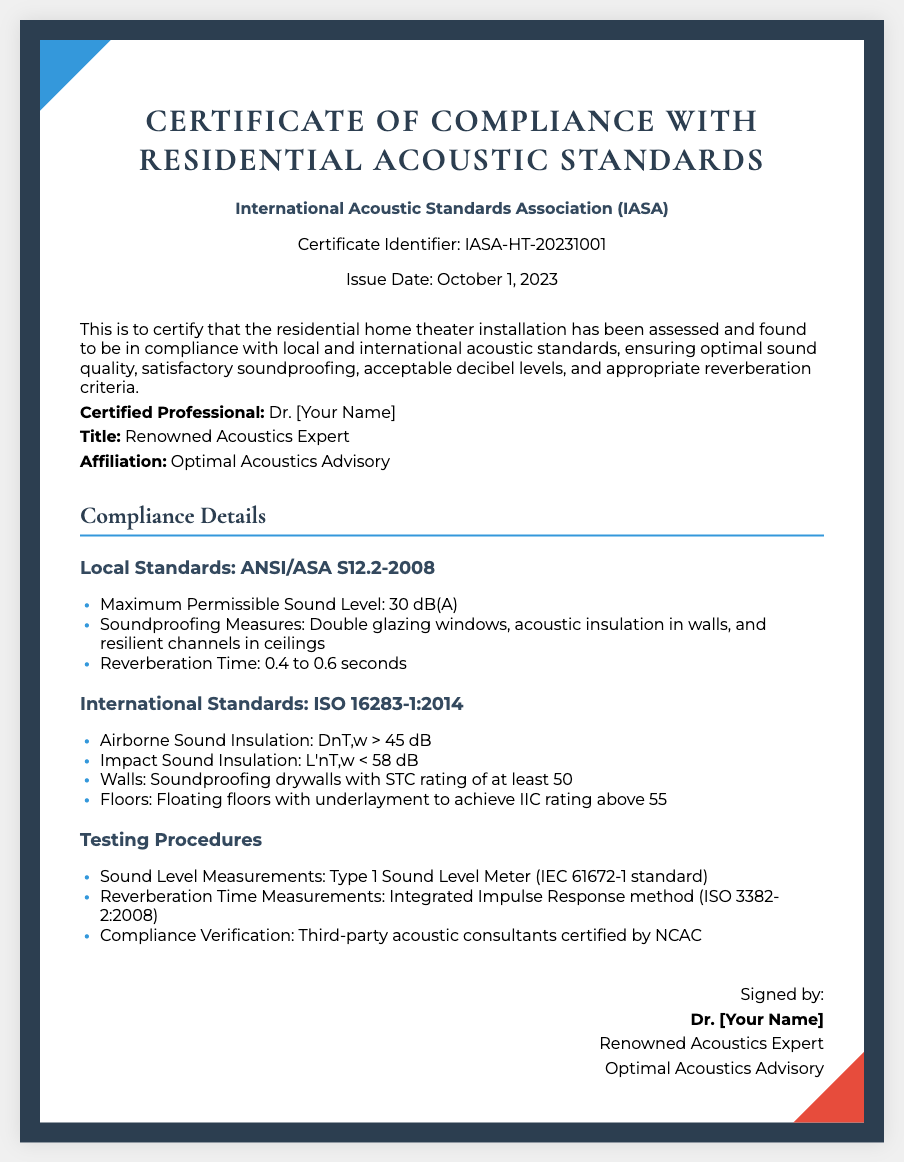What is the certificate identifier? The certificate identifier is specified in the document to uniquely identify the certificate issued.
Answer: IASA-HT-20231001 Who issued the certificate? The document states the certifying body responsible for the issuance of the certificate.
Answer: International Acoustic Standards Association (IASA) What is the maximum permissible sound level according to local standards? The document details the maximum permissible sound level as per local standards, which is mentioned in the compliance section.
Answer: 30 dB(A) What is the reverberation time stated in the compliance details? The document specifies the acceptable range for reverberation time under local standards for optimum sound quality.
Answer: 0.4 to 0.6 seconds What type of sound insulation is required for airborne sound? The compliance section mentions specific criteria for airborne sound insulation according to international standards.
Answer: DnT,w > 45 dB What is the title of the certified professional? The document includes the title of the certified professional who assessed the home theater installation.
Answer: Renowned Acoustics Expert What method is used for measuring reverberation time? The document outlines the testing procedure for measuring reverberation time, indicating the method employed.
Answer: Integrated Impulse Response method What is the affiliation of the certified professional? The document provides the affiliation of the certified professional indicating their expertise and organization.
Answer: Optimal Acoustics Advisory 